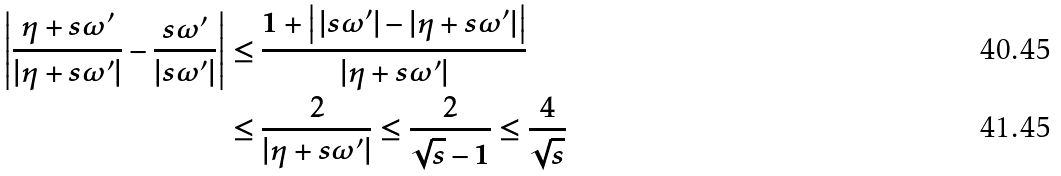Convert formula to latex. <formula><loc_0><loc_0><loc_500><loc_500>\left | \frac { \eta + s \omega ^ { \prime } } { | \eta + s \omega ^ { \prime } | } - \frac { s \omega ^ { \prime } } { | s \omega ^ { \prime } | } \right | & \leq \frac { 1 + \left | \, | s \omega ^ { \prime } | - | \eta + s \omega ^ { \prime } | \right | } { | \eta + s \omega ^ { \prime } | } \\ & \leq \frac { 2 } { | \eta + s \omega ^ { \prime } | } \leq \frac { 2 } { \sqrt { s } - 1 } \leq \frac { 4 } { \sqrt { s } }</formula> 